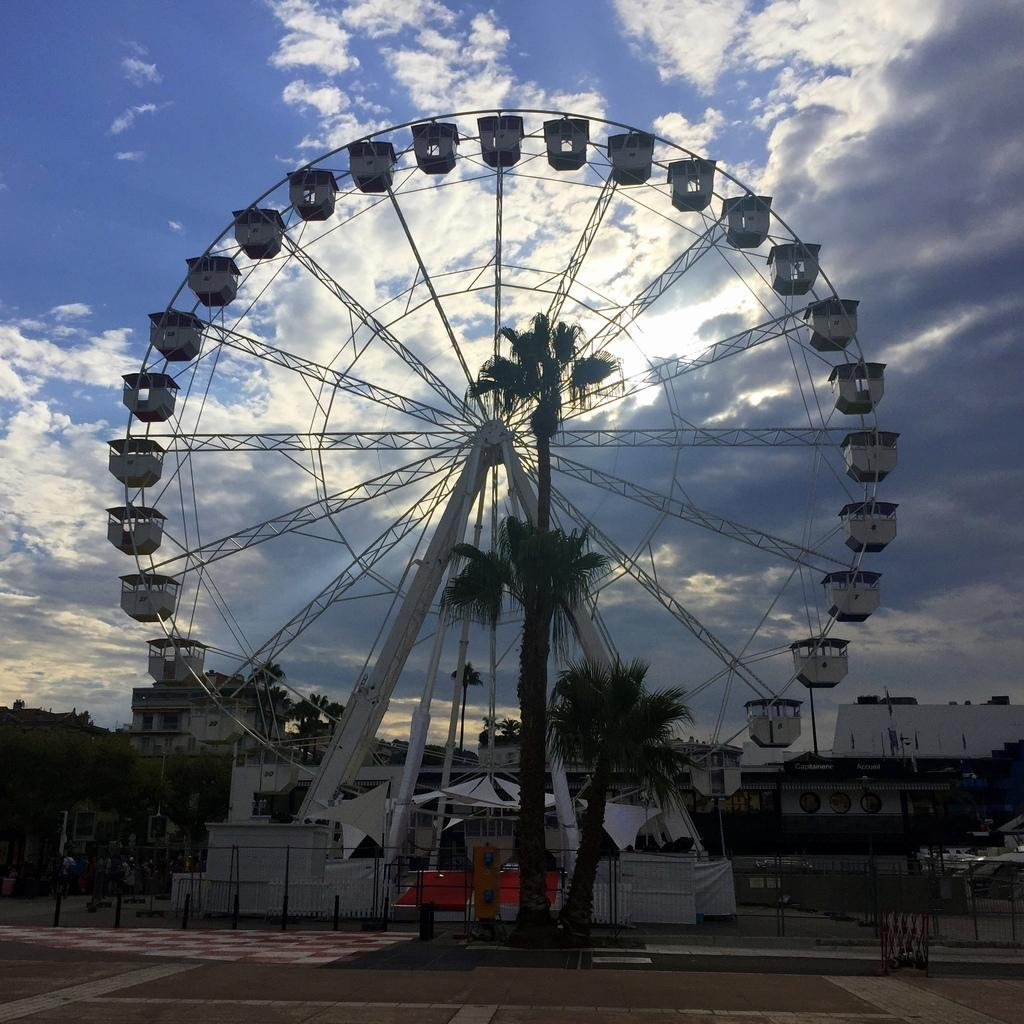What is the main subject in the picture? There is a giant wheel in the picture. What can be seen in the background of the picture? There are trees, buildings, and people in the background of the picture. What type of mitten is being used to hold the giant wheel in the picture? There is no mitten present in the image, and the giant wheel is not being held by any object or person. 